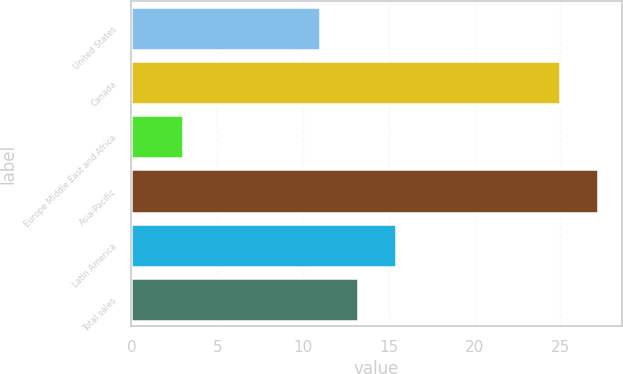<chart> <loc_0><loc_0><loc_500><loc_500><bar_chart><fcel>United States<fcel>Canada<fcel>Europe Middle East and Africa<fcel>Asia-Pacific<fcel>Latin America<fcel>Total sales<nl><fcel>11<fcel>25<fcel>3<fcel>27.2<fcel>15.4<fcel>13.2<nl></chart> 